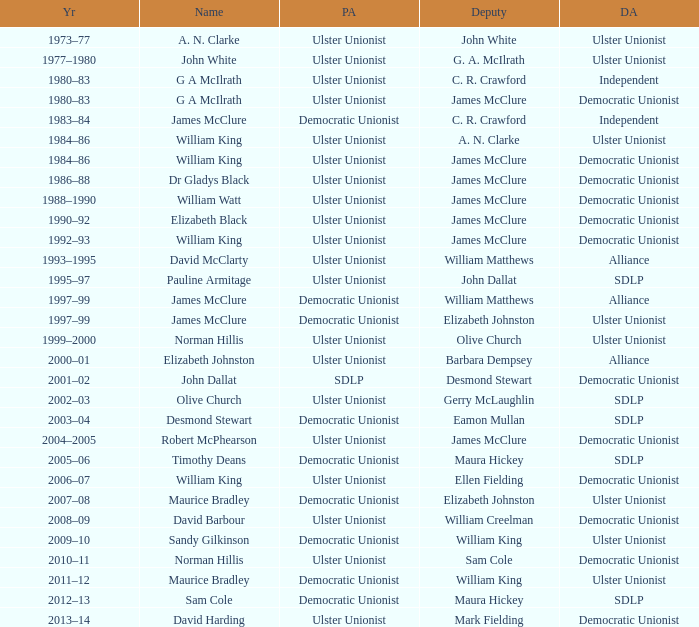What is the Name for 1997–99? James McClure, James McClure. 